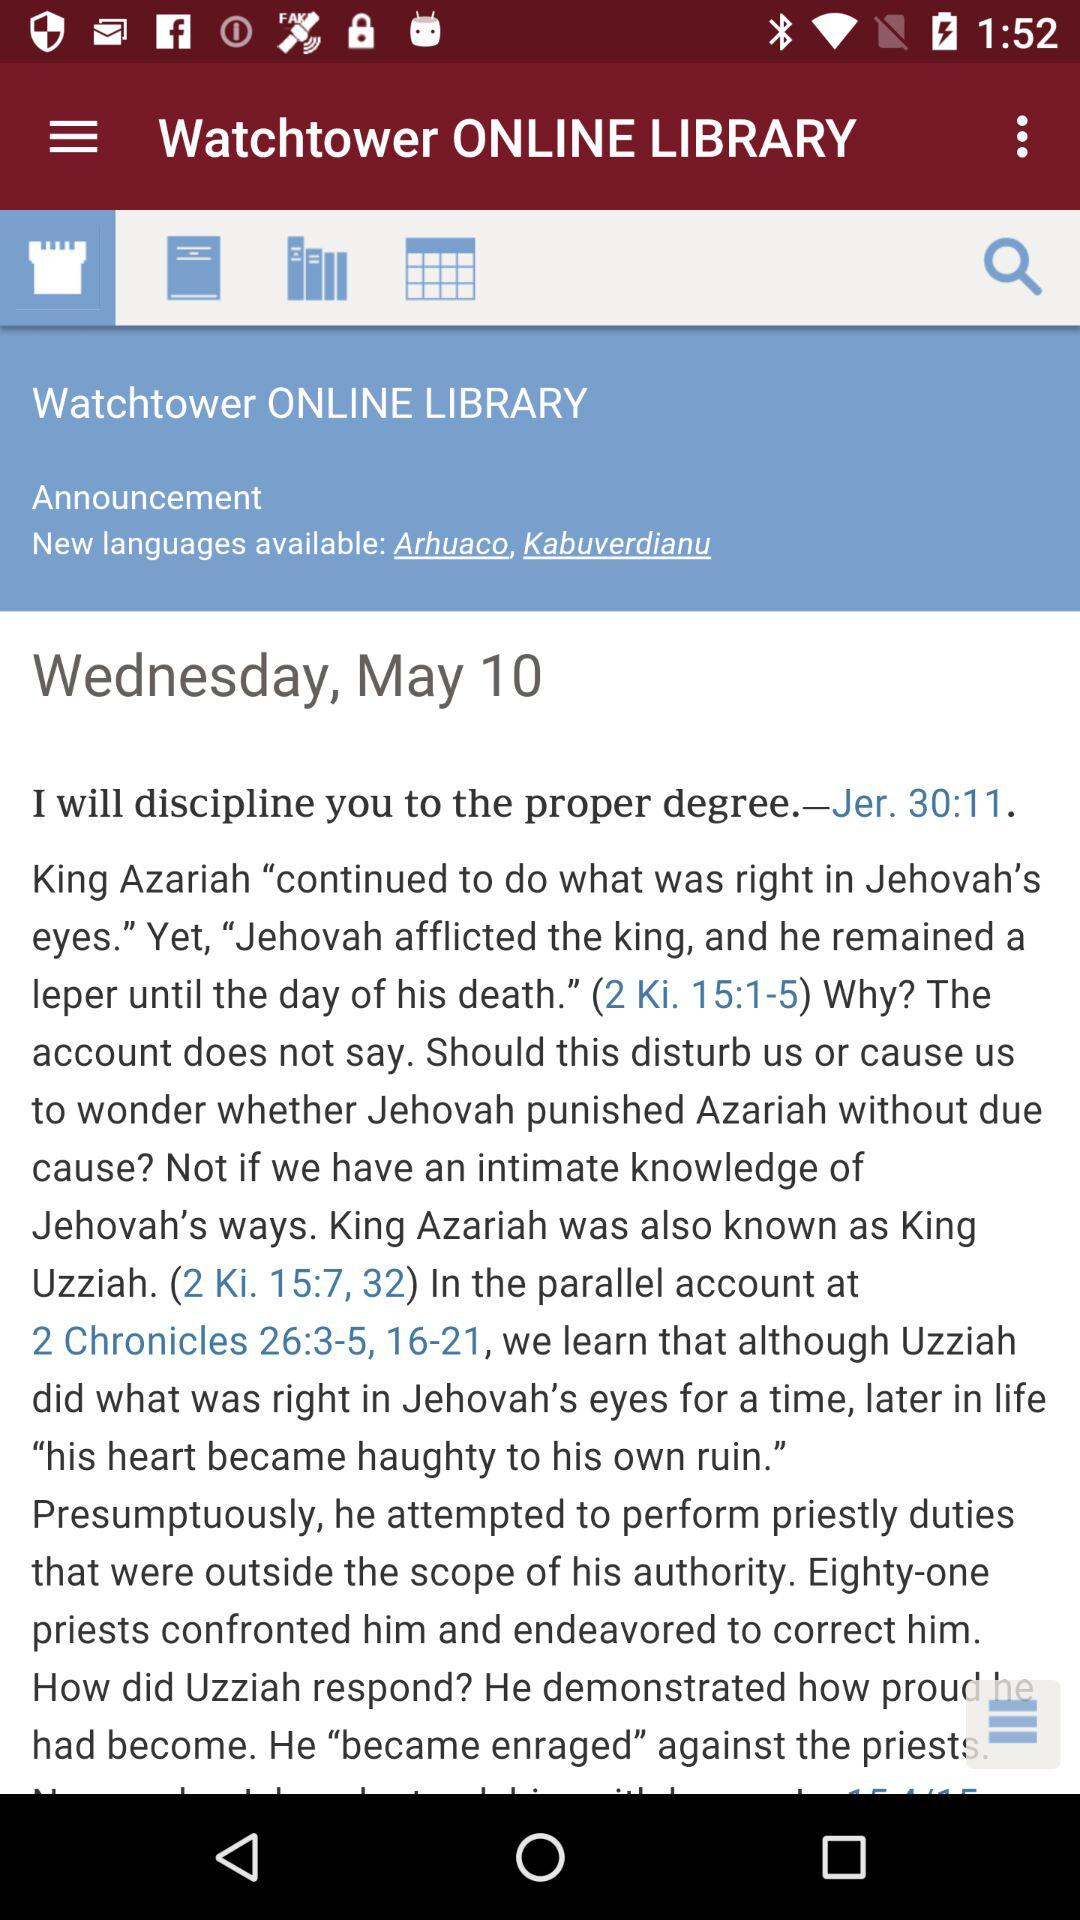How many languages have been added since the last announcement?
Answer the question using a single word or phrase. 2 